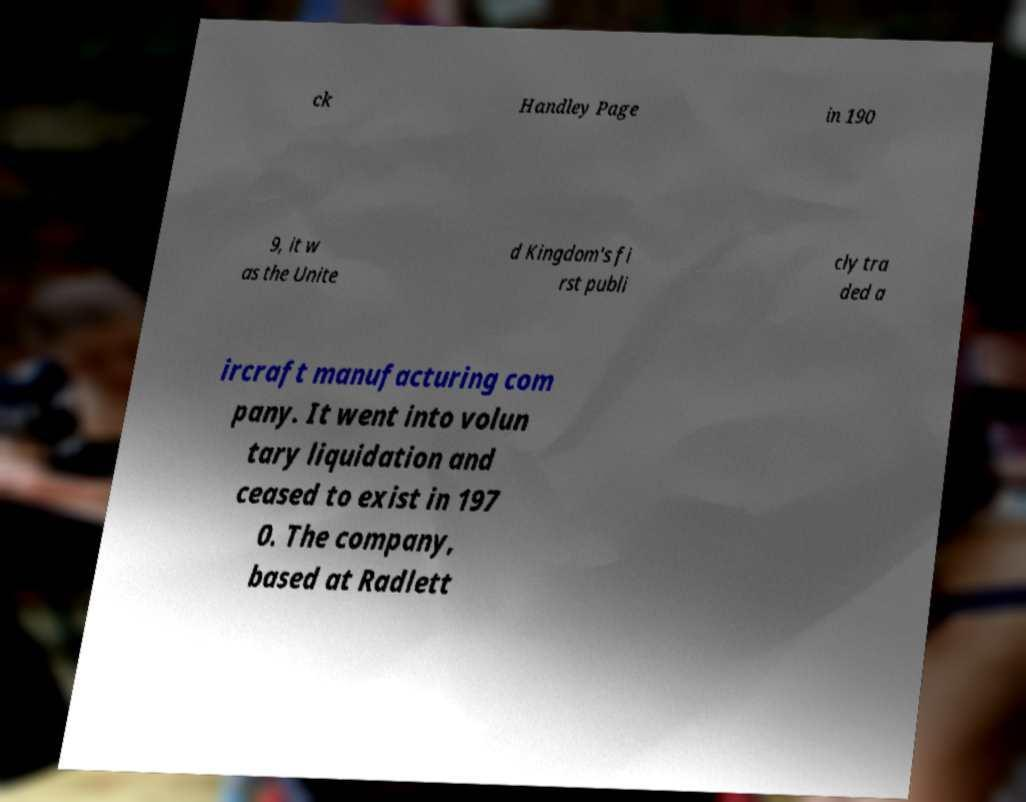Please read and relay the text visible in this image. What does it say? ck Handley Page in 190 9, it w as the Unite d Kingdom's fi rst publi cly tra ded a ircraft manufacturing com pany. It went into volun tary liquidation and ceased to exist in 197 0. The company, based at Radlett 